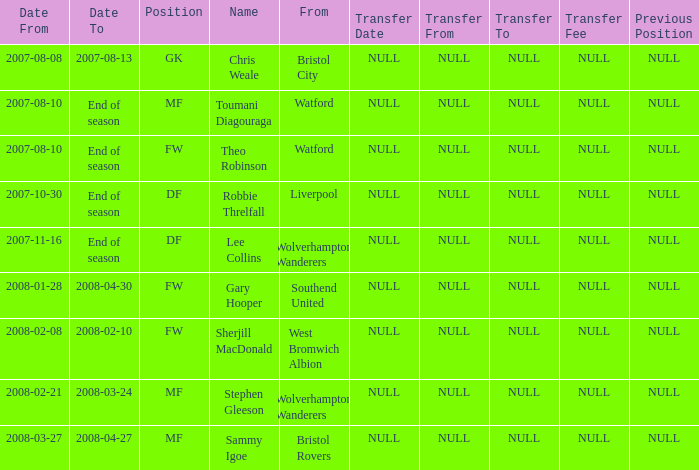What was the name for the row with Date From of 2008-02-21? Stephen Gleeson. 